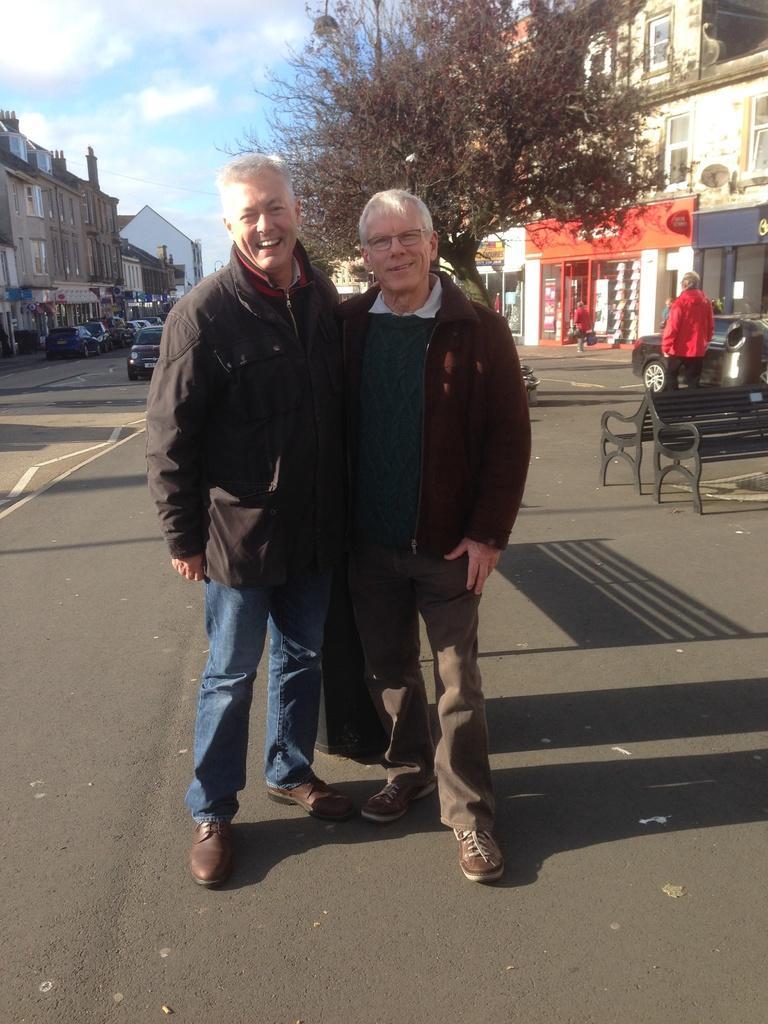How would you summarize this image in a sentence or two? In the image there are two old men in jackets standing on the road, on either side of it there are buildings with trees and vehicles in front of it. 